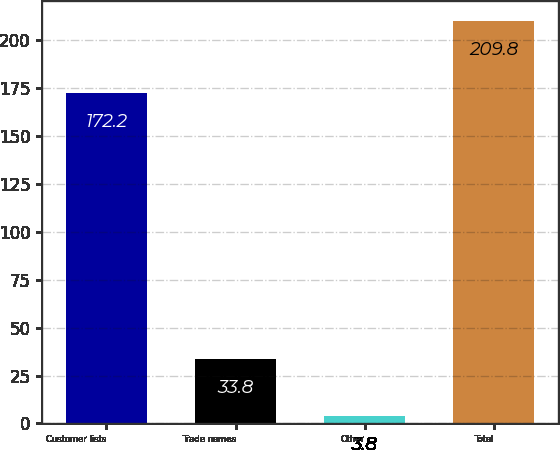Convert chart. <chart><loc_0><loc_0><loc_500><loc_500><bar_chart><fcel>Customer lists<fcel>Trade names<fcel>Other<fcel>Total<nl><fcel>172.2<fcel>33.8<fcel>3.8<fcel>209.8<nl></chart> 